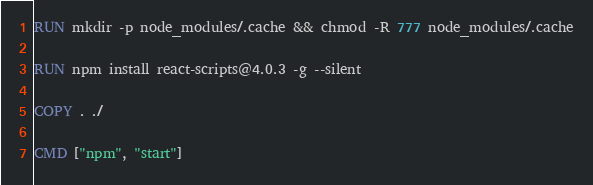Convert code to text. <code><loc_0><loc_0><loc_500><loc_500><_Dockerfile_>
RUN mkdir -p node_modules/.cache && chmod -R 777 node_modules/.cache

RUN npm install react-scripts@4.0.3 -g --silent

COPY . ./

CMD ["npm", "start"]
</code> 